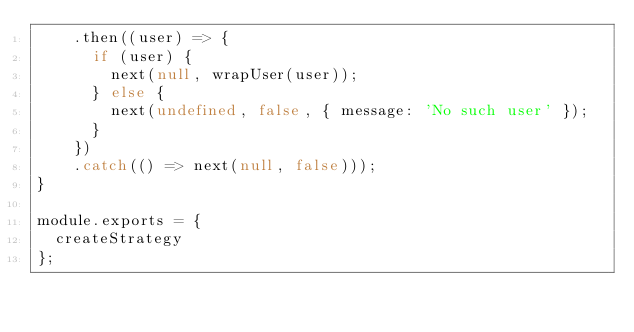Convert code to text. <code><loc_0><loc_0><loc_500><loc_500><_JavaScript_>    .then((user) => {
      if (user) {
        next(null, wrapUser(user));
      } else {
        next(undefined, false, { message: 'No such user' });
      }
    })
    .catch(() => next(null, false)));
}

module.exports = {
  createStrategy
};
</code> 